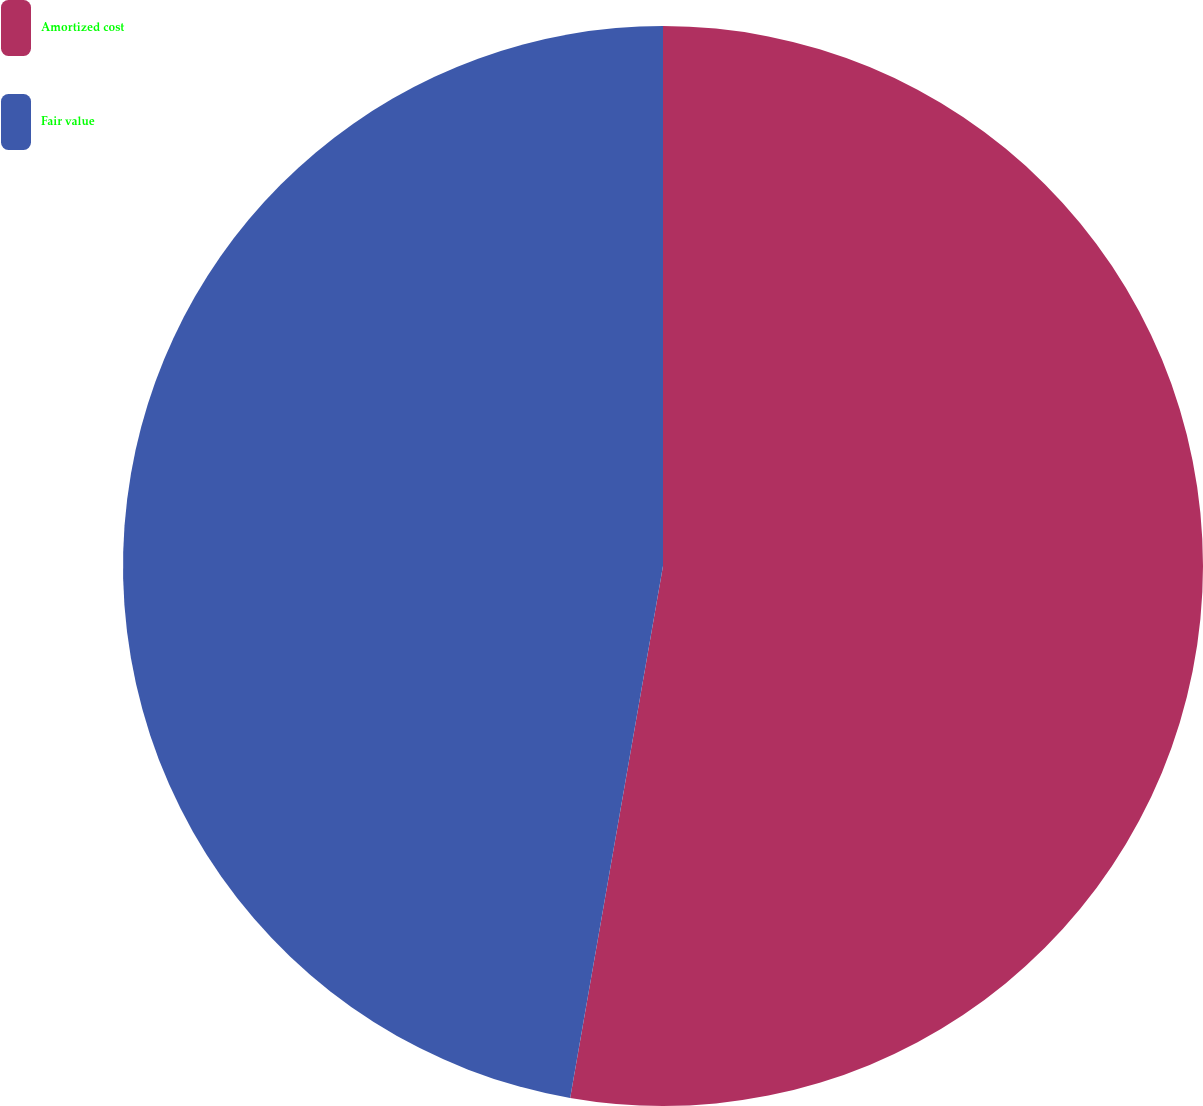Convert chart to OTSL. <chart><loc_0><loc_0><loc_500><loc_500><pie_chart><fcel>Amortized cost<fcel>Fair value<nl><fcel>52.75%<fcel>47.25%<nl></chart> 